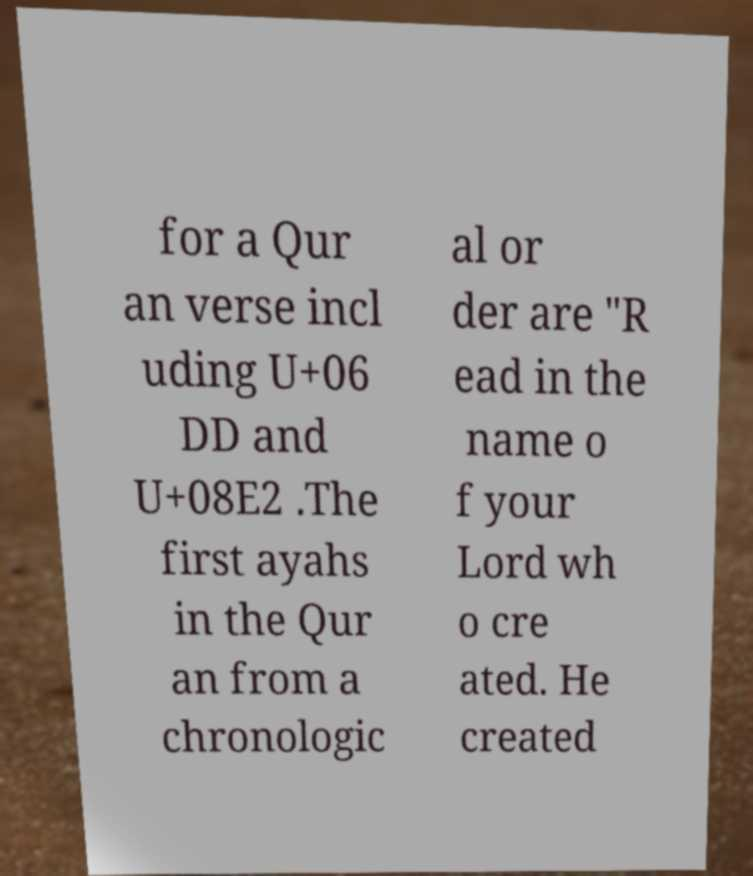What messages or text are displayed in this image? I need them in a readable, typed format. for a Qur an verse incl uding U+06 DD and U+08E2 .The first ayahs in the Qur an from a chronologic al or der are "R ead in the name o f your Lord wh o cre ated. He created 